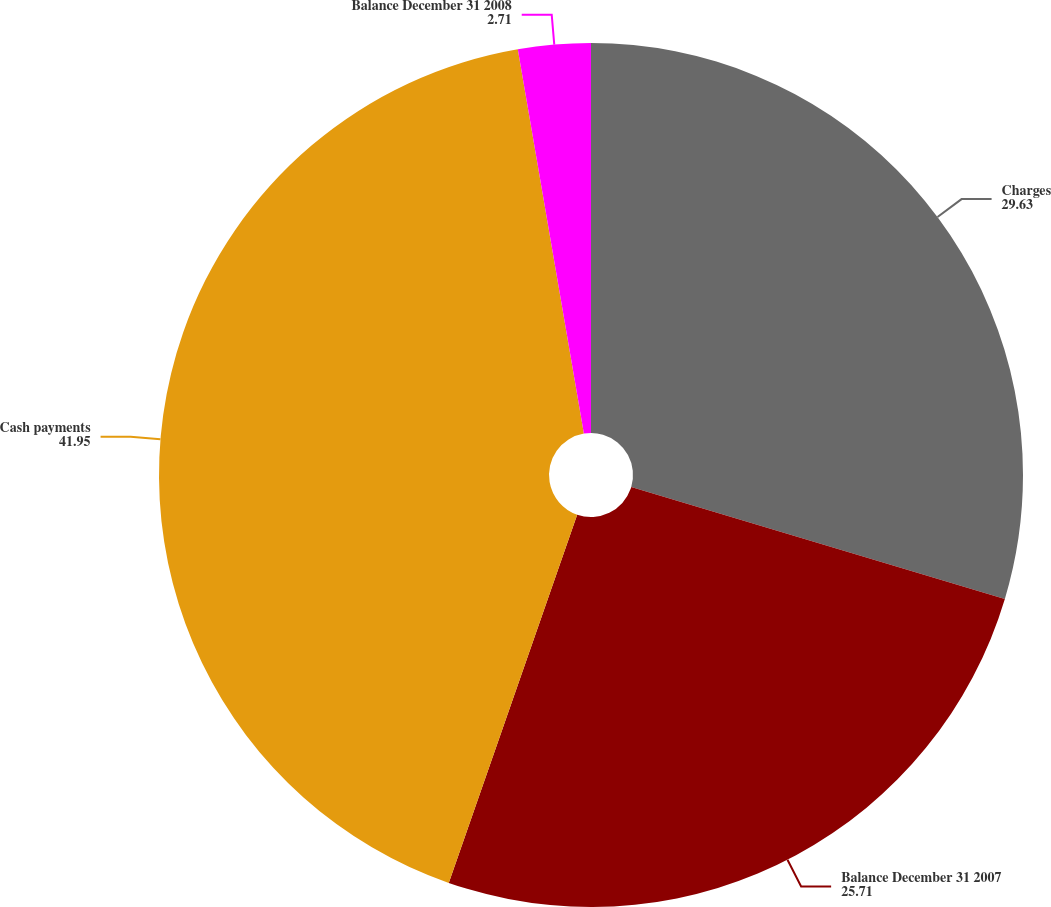Convert chart. <chart><loc_0><loc_0><loc_500><loc_500><pie_chart><fcel>Charges<fcel>Balance December 31 2007<fcel>Cash payments<fcel>Balance December 31 2008<nl><fcel>29.63%<fcel>25.71%<fcel>41.95%<fcel>2.71%<nl></chart> 